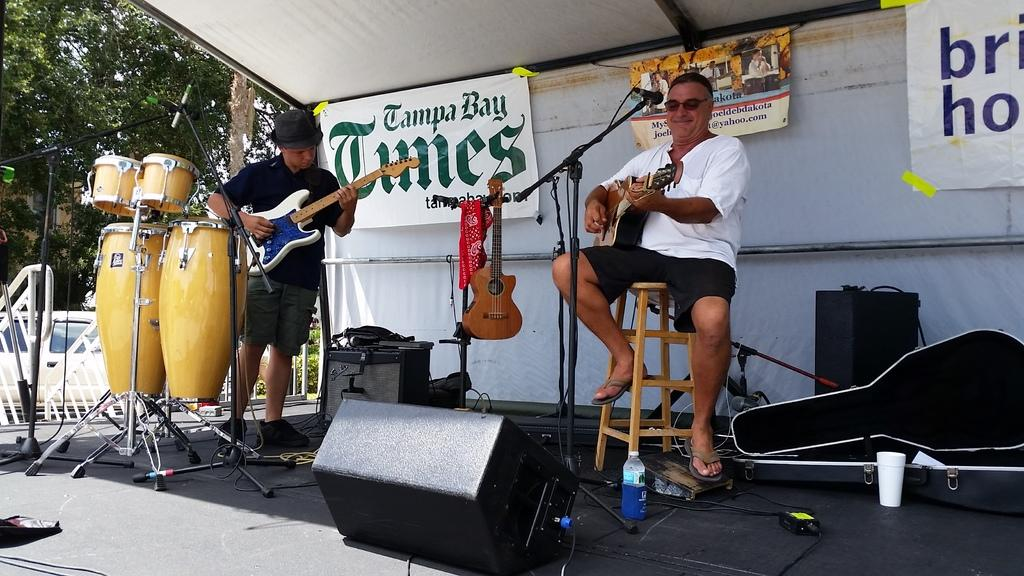How many people are in the image? There are two persons in the image. What are the persons doing in the image? The persons are playing musical instruments. What can be seen in the background of the image? There is a tree visible in the background of the image. What type of pest can be seen crawling on the cloth in the image? There is no cloth or pest present in the image. 